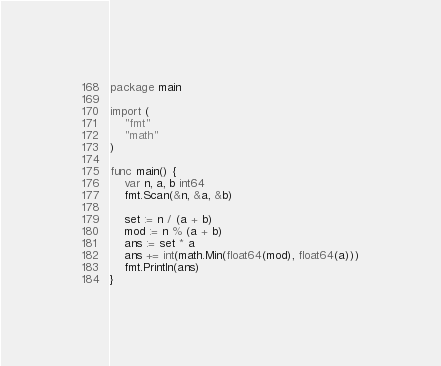<code> <loc_0><loc_0><loc_500><loc_500><_Go_>package main

import (
	"fmt"
	"math"
)

func main() {
	var n, a, b int64
	fmt.Scan(&n, &a, &b)

	set := n / (a + b)
	mod := n % (a + b)
	ans := set * a
	ans += int(math.Min(float64(mod), float64(a)))
	fmt.Println(ans)
}
</code> 